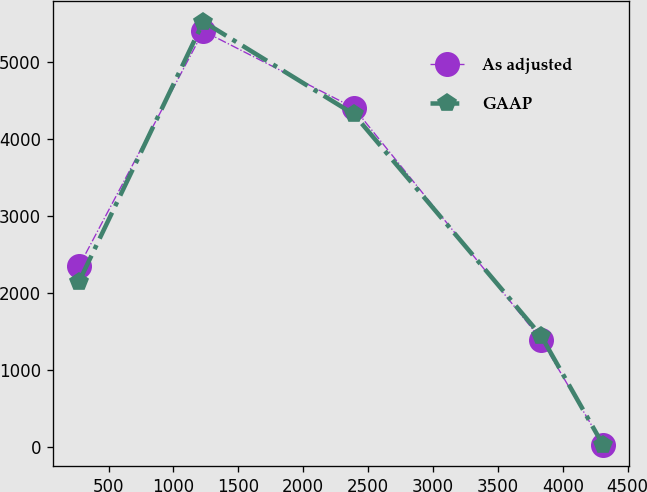Convert chart to OTSL. <chart><loc_0><loc_0><loc_500><loc_500><line_chart><ecel><fcel>As adjusted<fcel>GAAP<nl><fcel>272.06<fcel>2347.64<fcel>2147.11<nl><fcel>1230.66<fcel>5408.03<fcel>5529.93<nl><fcel>2389.56<fcel>4409.48<fcel>4326.41<nl><fcel>3832.64<fcel>1393.09<fcel>1442<nl><fcel>4309.46<fcel>26.57<fcel>23.92<nl></chart> 